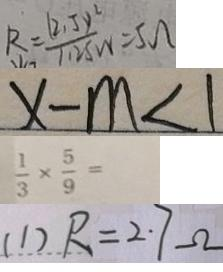Convert formula to latex. <formula><loc_0><loc_0><loc_500><loc_500>R = \frac { ( 2 . 5 y ^ { 2 } ) } { 1 . 2 5 w } = 5 \Omega 
 x - m < 1 
 \frac { 1 } { 3 } \times \frac { 5 } { 9 } = 
 ( 1 ) R = 2 . 7 \Omega</formula> 